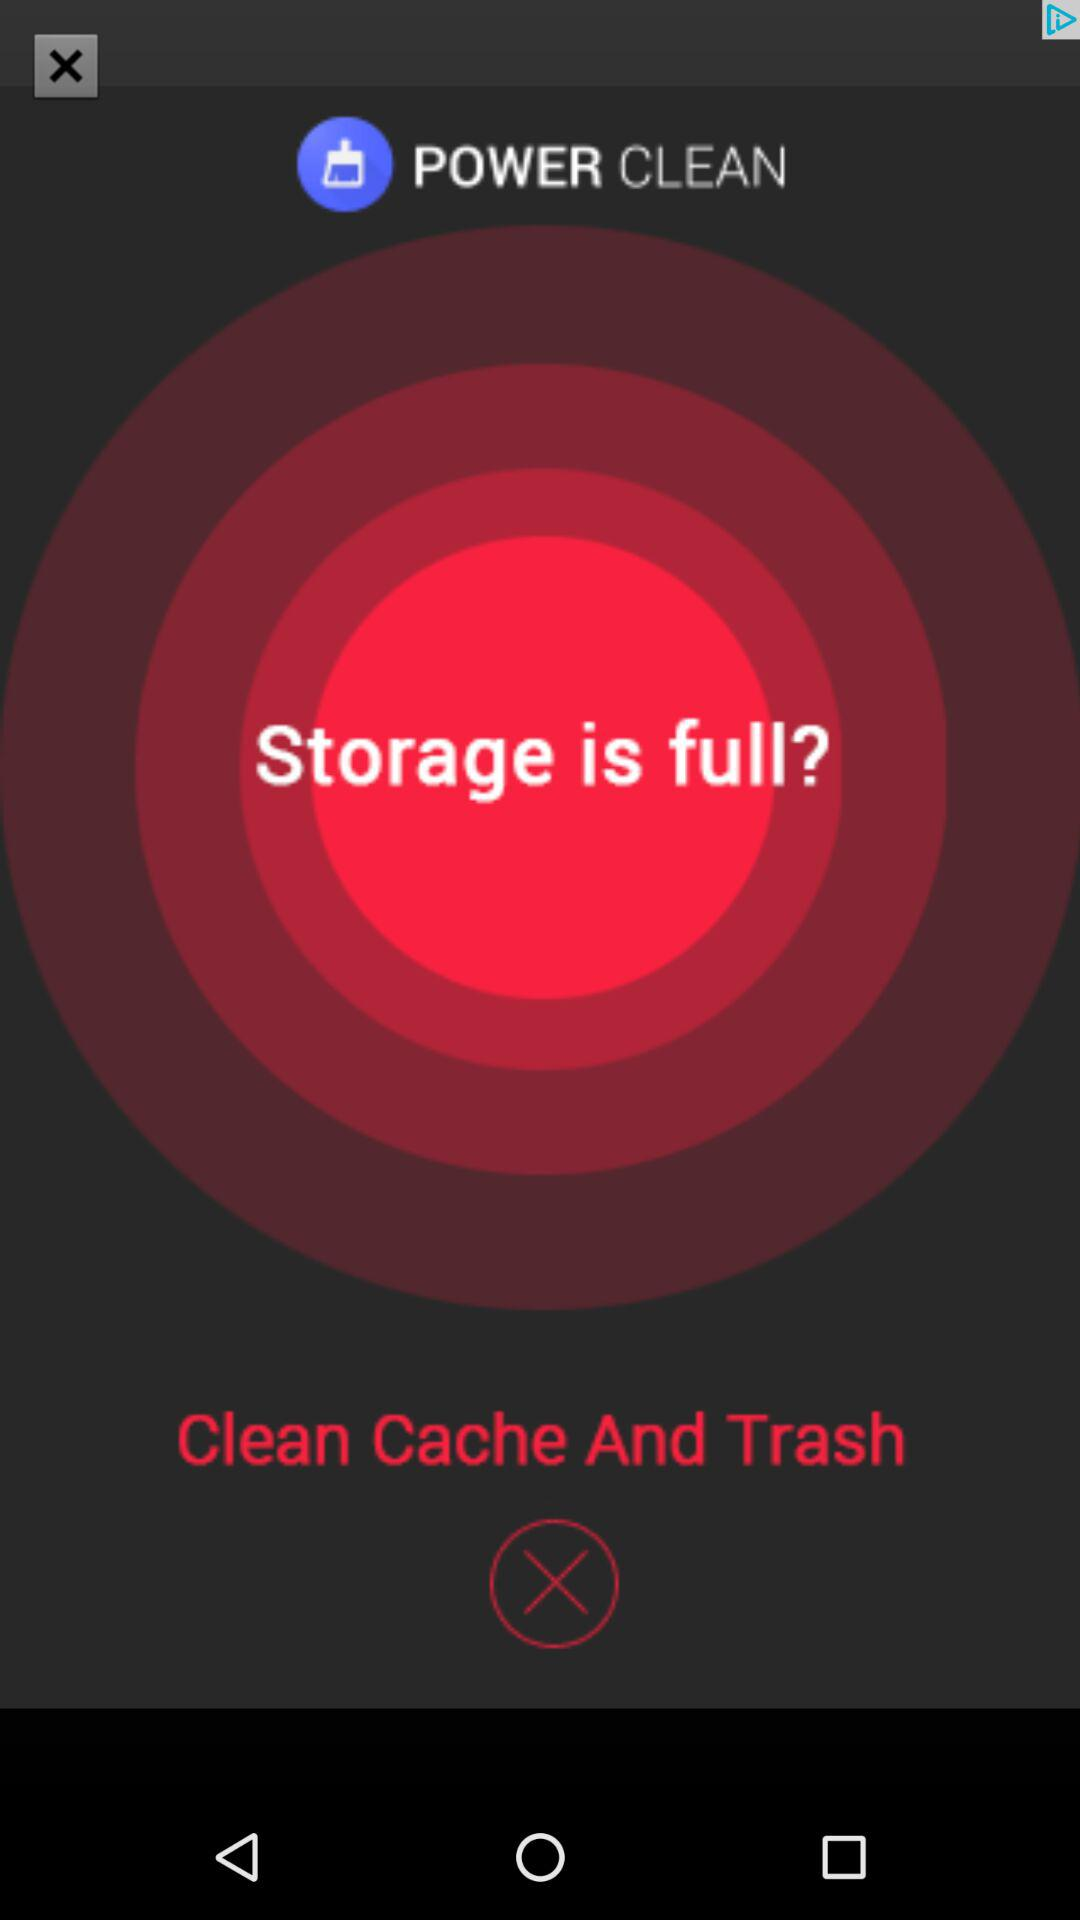What is the application name? The application name is "POWER CLEAN". 